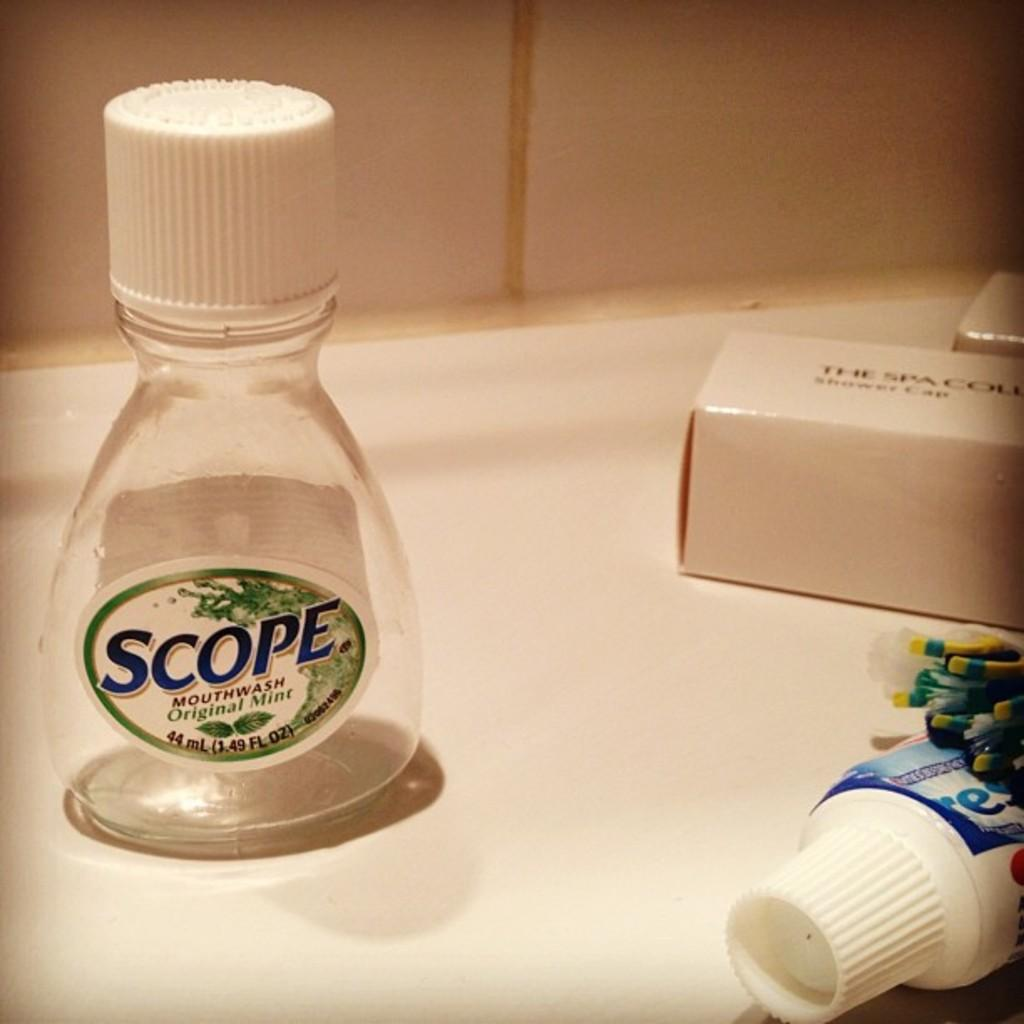Provide a one-sentence caption for the provided image. Scope mouth wash and crest toothpaste along with a shower cap. 